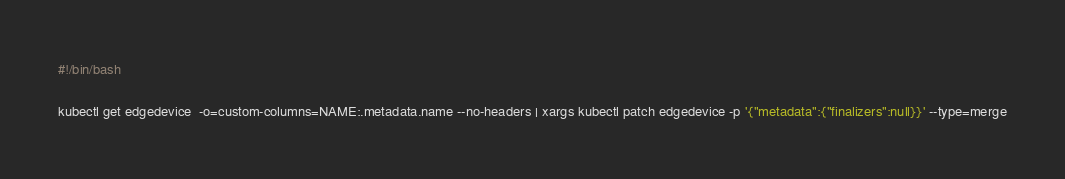<code> <loc_0><loc_0><loc_500><loc_500><_Bash_>#!/bin/bash

kubectl get edgedevice  -o=custom-columns=NAME:.metadata.name --no-headers | xargs kubectl patch edgedevice -p '{"metadata":{"finalizers":null}}' --type=merge</code> 